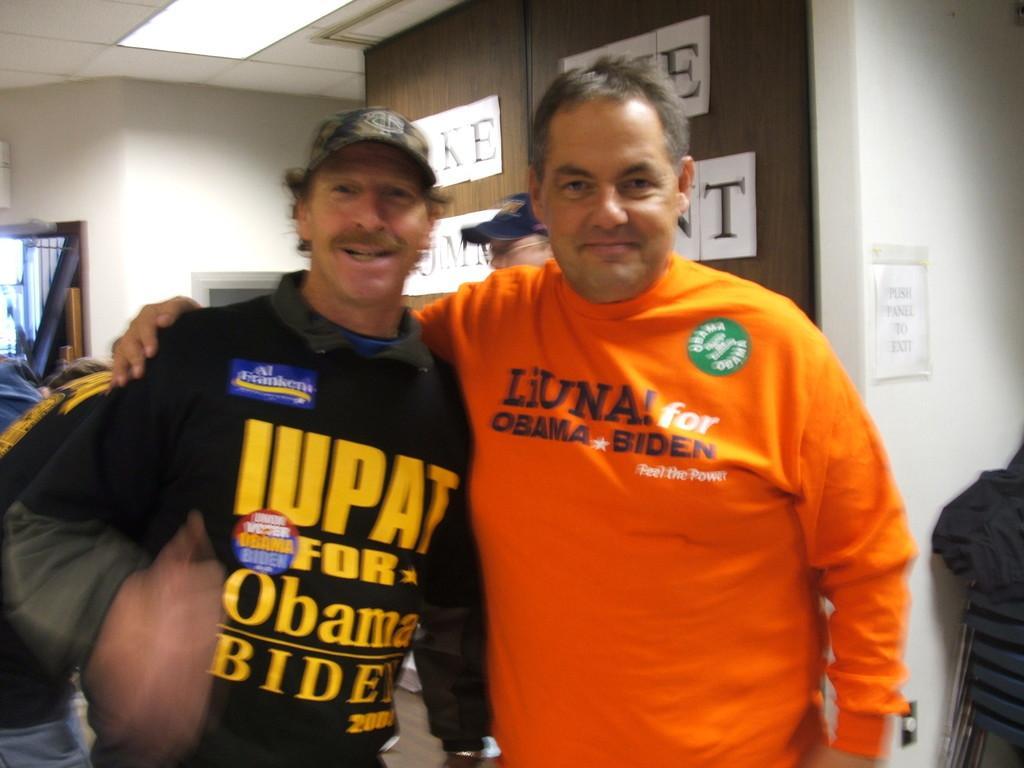How would you summarize this image in a sentence or two? In this image, there are two men standing. On the right side of the image, I can see a poster attached to a wall and the chairs. In the background, I can see another person standing and a cupboard with the doors. At the top of the image, this is the ceiling light, which is attached to the ceiling. 